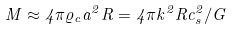Convert formula to latex. <formula><loc_0><loc_0><loc_500><loc_500>M \approx 4 \pi \varrho _ { c } a ^ { 2 } R = 4 \pi k ^ { 2 } R c _ { s } ^ { 2 } / G</formula> 